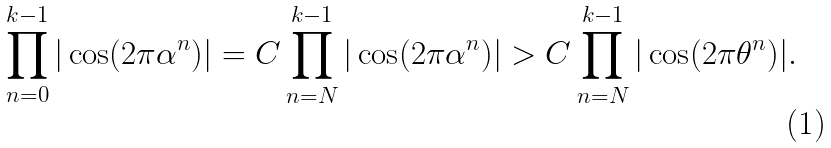<formula> <loc_0><loc_0><loc_500><loc_500>\prod _ { n = 0 } ^ { k - 1 } | \cos ( 2 \pi \alpha ^ { n } ) | = C \prod _ { n = N } ^ { k - 1 } | \cos ( 2 \pi \alpha ^ { n } ) | > C \prod _ { n = N } ^ { k - 1 } | \cos ( 2 \pi \theta ^ { n } ) | .</formula> 